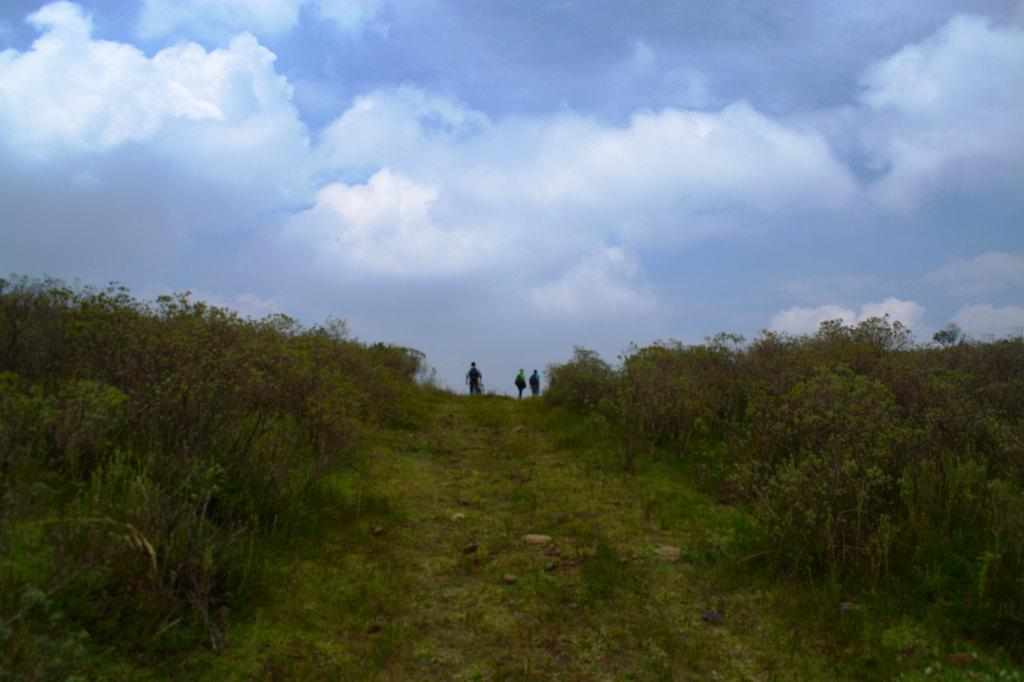What is the main feature of the landscape in the image? There is a slope in the image. What covers the slope in the image? The slope is filled with grass and plants. How many people are above the slope in the image? There are three people above the slope in the image. What can be seen in the background of the image? The sky is visible in the background of the image. What type of treatment is the carpenter applying to the soap in the image? There is no carpenter or soap present in the image; it features a slope filled with grass and plants, with three people above it and the sky visible in the background. 